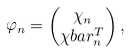Convert formula to latex. <formula><loc_0><loc_0><loc_500><loc_500>\varphi _ { n } & = \begin{pmatrix} \chi _ { n } \\ \chi b a r _ { n } ^ { T } \end{pmatrix} ,</formula> 